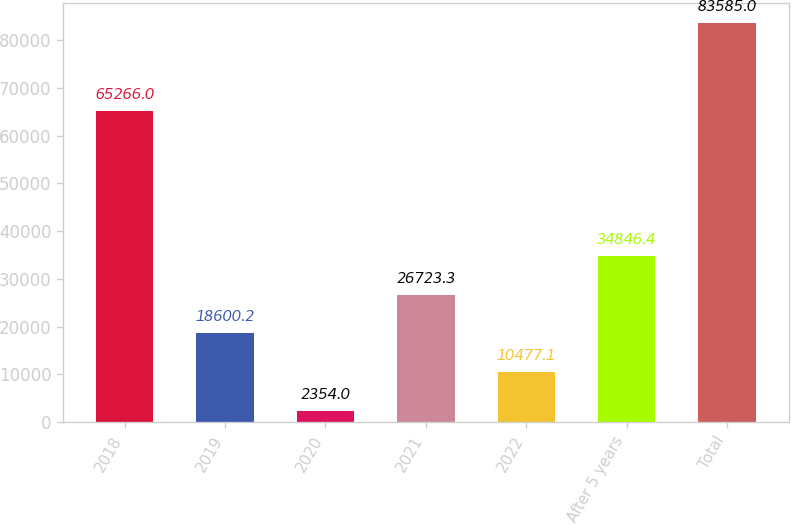Convert chart to OTSL. <chart><loc_0><loc_0><loc_500><loc_500><bar_chart><fcel>2018<fcel>2019<fcel>2020<fcel>2021<fcel>2022<fcel>After 5 years<fcel>Total<nl><fcel>65266<fcel>18600.2<fcel>2354<fcel>26723.3<fcel>10477.1<fcel>34846.4<fcel>83585<nl></chart> 